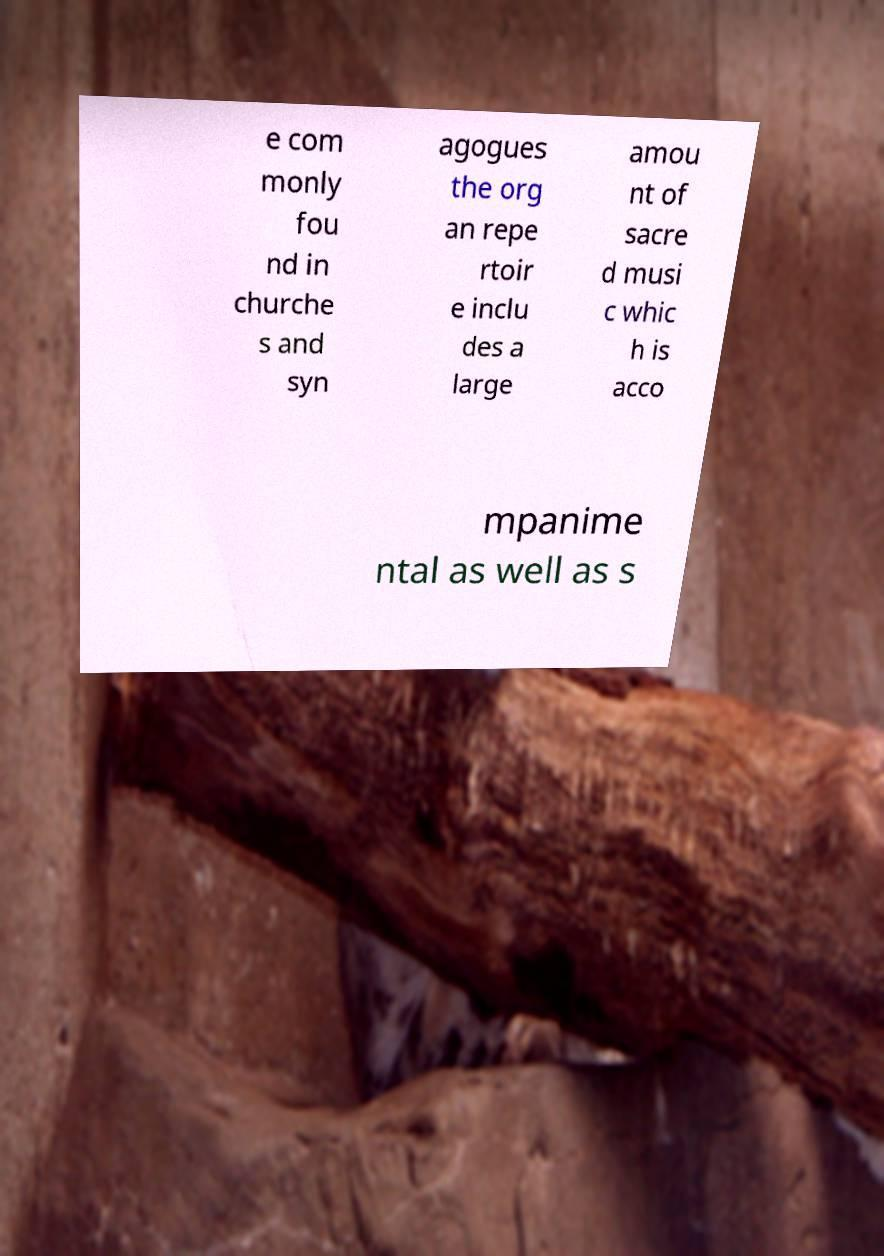Please identify and transcribe the text found in this image. e com monly fou nd in churche s and syn agogues the org an repe rtoir e inclu des a large amou nt of sacre d musi c whic h is acco mpanime ntal as well as s 